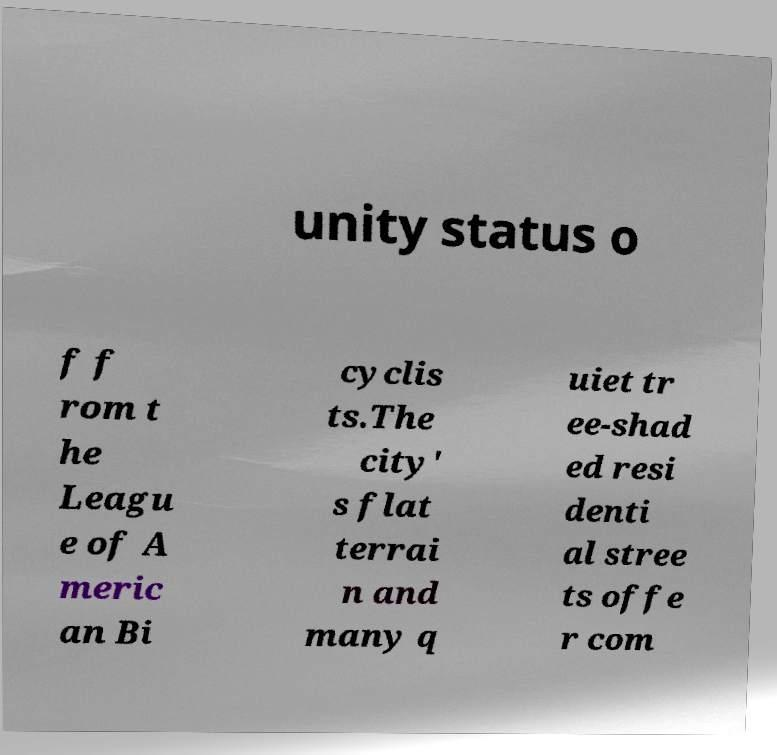Could you assist in decoding the text presented in this image and type it out clearly? unity status o f f rom t he Leagu e of A meric an Bi cyclis ts.The city' s flat terrai n and many q uiet tr ee-shad ed resi denti al stree ts offe r com 